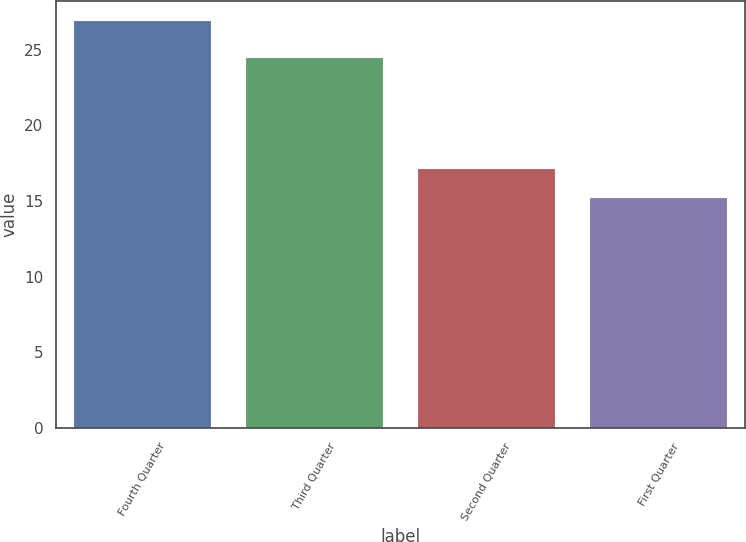<chart> <loc_0><loc_0><loc_500><loc_500><bar_chart><fcel>Fourth Quarter<fcel>Third Quarter<fcel>Second Quarter<fcel>First Quarter<nl><fcel>26.89<fcel>24.42<fcel>17.09<fcel>15.18<nl></chart> 